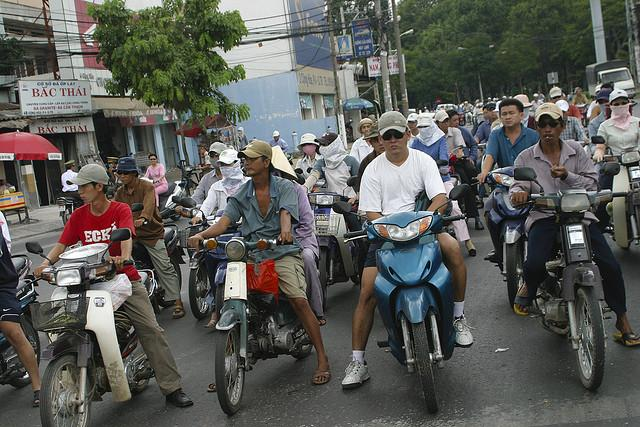What type of area is shown?

Choices:
A) coastal
B) rural
C) urban
D) forest urban 